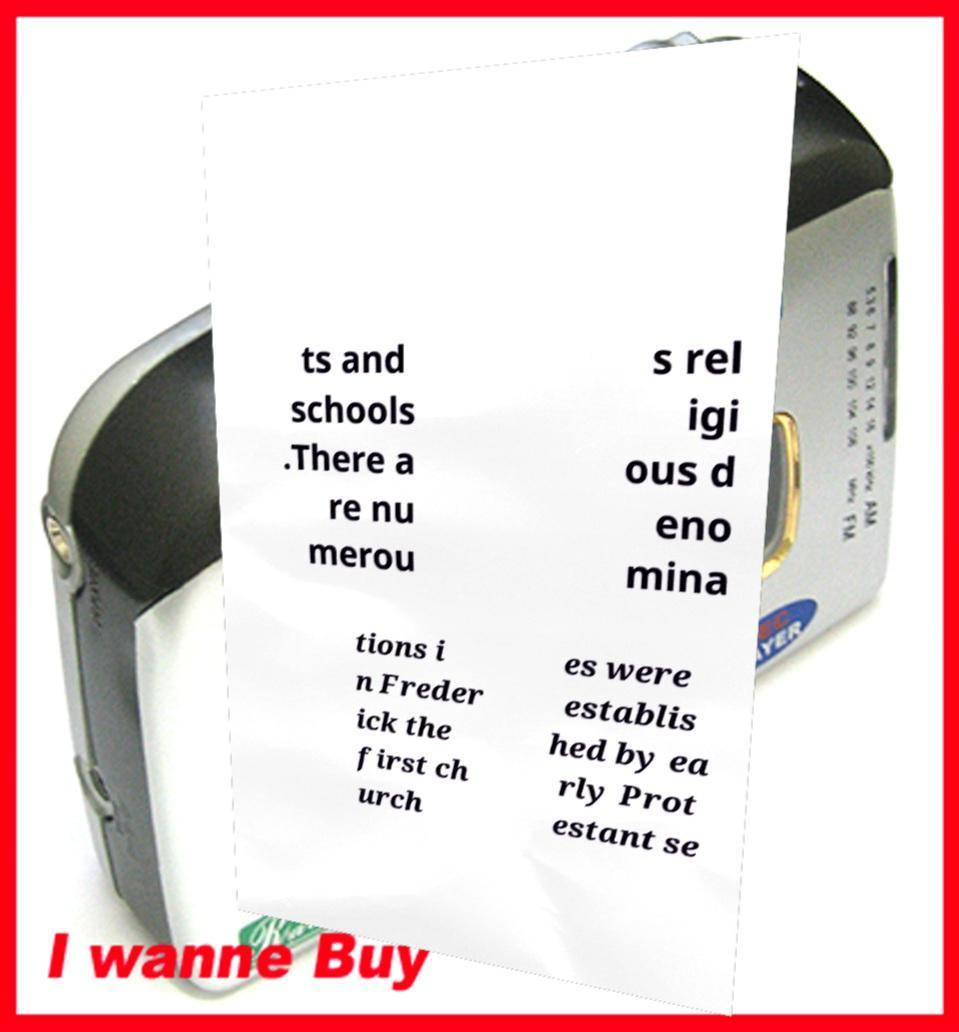Could you assist in decoding the text presented in this image and type it out clearly? ts and schools .There a re nu merou s rel igi ous d eno mina tions i n Freder ick the first ch urch es were establis hed by ea rly Prot estant se 